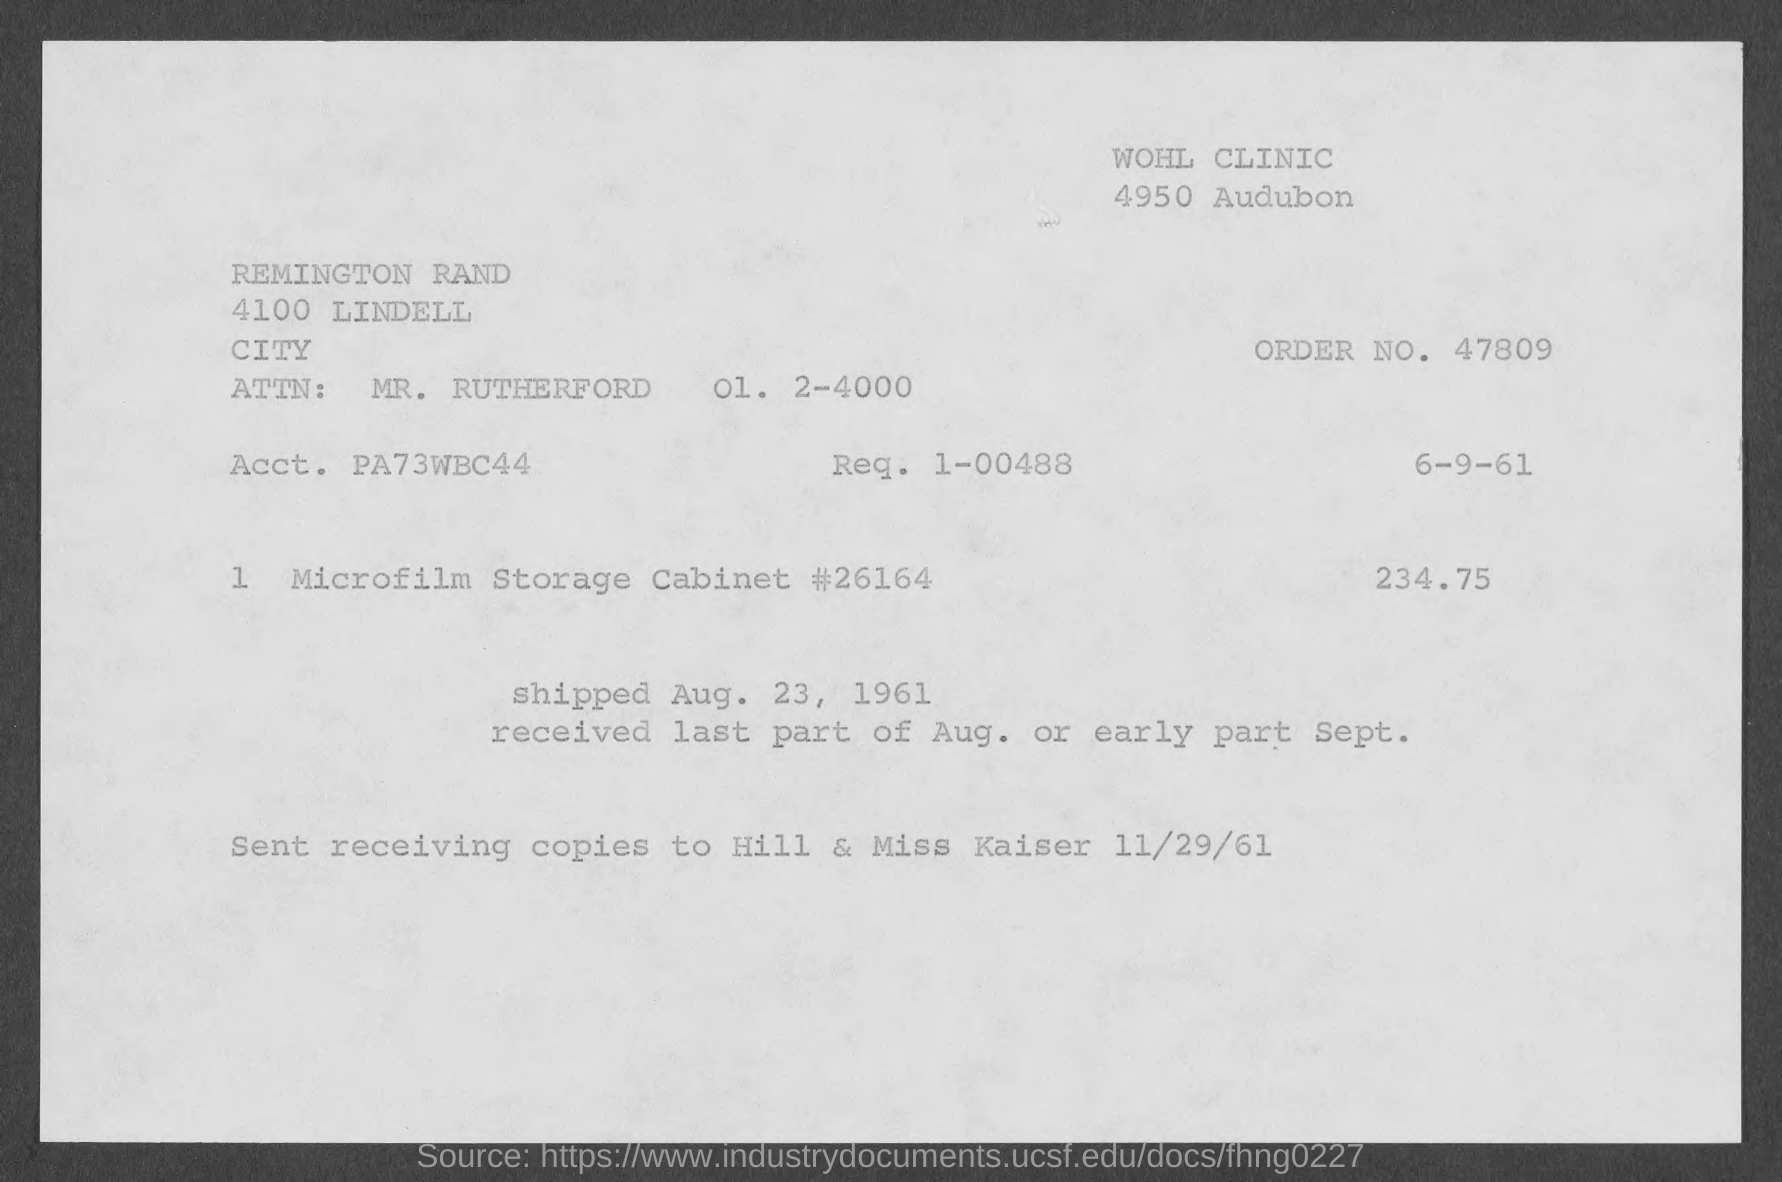Highlight a few significant elements in this photo. The attention of MR. Rutherford is mentioned in the given form. The shipped date mentioned on the given page is Aug. 23, 1961. The order number mentioned on the given page is 47809. The amount mentioned in the given form is 234.75... 